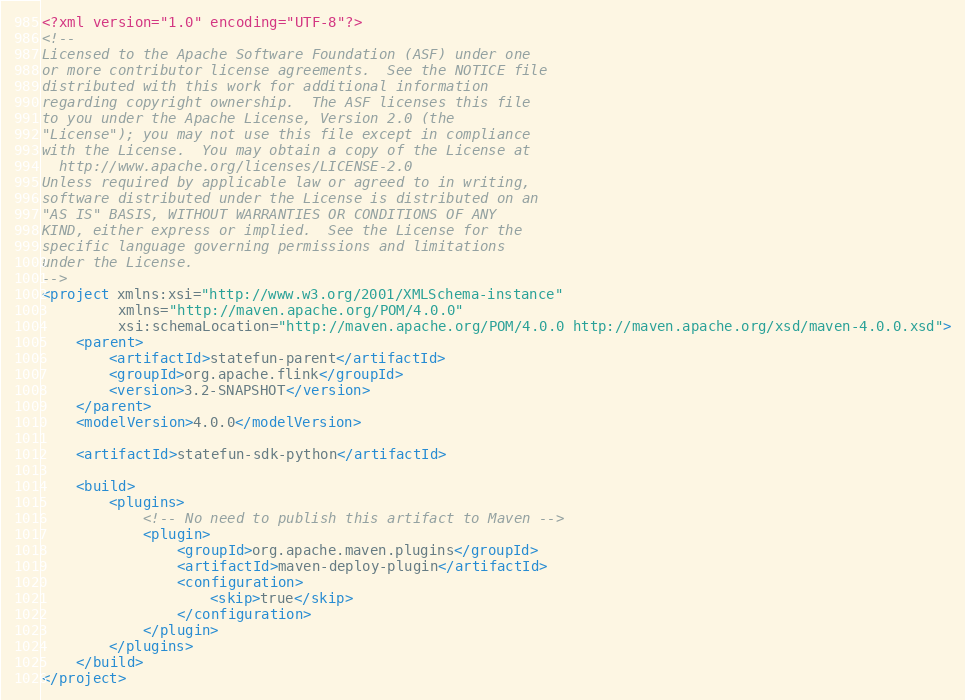<code> <loc_0><loc_0><loc_500><loc_500><_XML_><?xml version="1.0" encoding="UTF-8"?>
<!--
Licensed to the Apache Software Foundation (ASF) under one
or more contributor license agreements.  See the NOTICE file
distributed with this work for additional information
regarding copyright ownership.  The ASF licenses this file
to you under the Apache License, Version 2.0 (the
"License"); you may not use this file except in compliance
with the License.  You may obtain a copy of the License at
  http://www.apache.org/licenses/LICENSE-2.0
Unless required by applicable law or agreed to in writing,
software distributed under the License is distributed on an
"AS IS" BASIS, WITHOUT WARRANTIES OR CONDITIONS OF ANY
KIND, either express or implied.  See the License for the
specific language governing permissions and limitations
under the License.
-->
<project xmlns:xsi="http://www.w3.org/2001/XMLSchema-instance"
         xmlns="http://maven.apache.org/POM/4.0.0"
         xsi:schemaLocation="http://maven.apache.org/POM/4.0.0 http://maven.apache.org/xsd/maven-4.0.0.xsd">
    <parent>
        <artifactId>statefun-parent</artifactId>
        <groupId>org.apache.flink</groupId>
        <version>3.2-SNAPSHOT</version>
    </parent>
    <modelVersion>4.0.0</modelVersion>

    <artifactId>statefun-sdk-python</artifactId>

    <build>
        <plugins>
            <!-- No need to publish this artifact to Maven -->
            <plugin>
                <groupId>org.apache.maven.plugins</groupId>
                <artifactId>maven-deploy-plugin</artifactId>
                <configuration>
                    <skip>true</skip>
                </configuration>
            </plugin>
        </plugins>
    </build>
</project>
</code> 